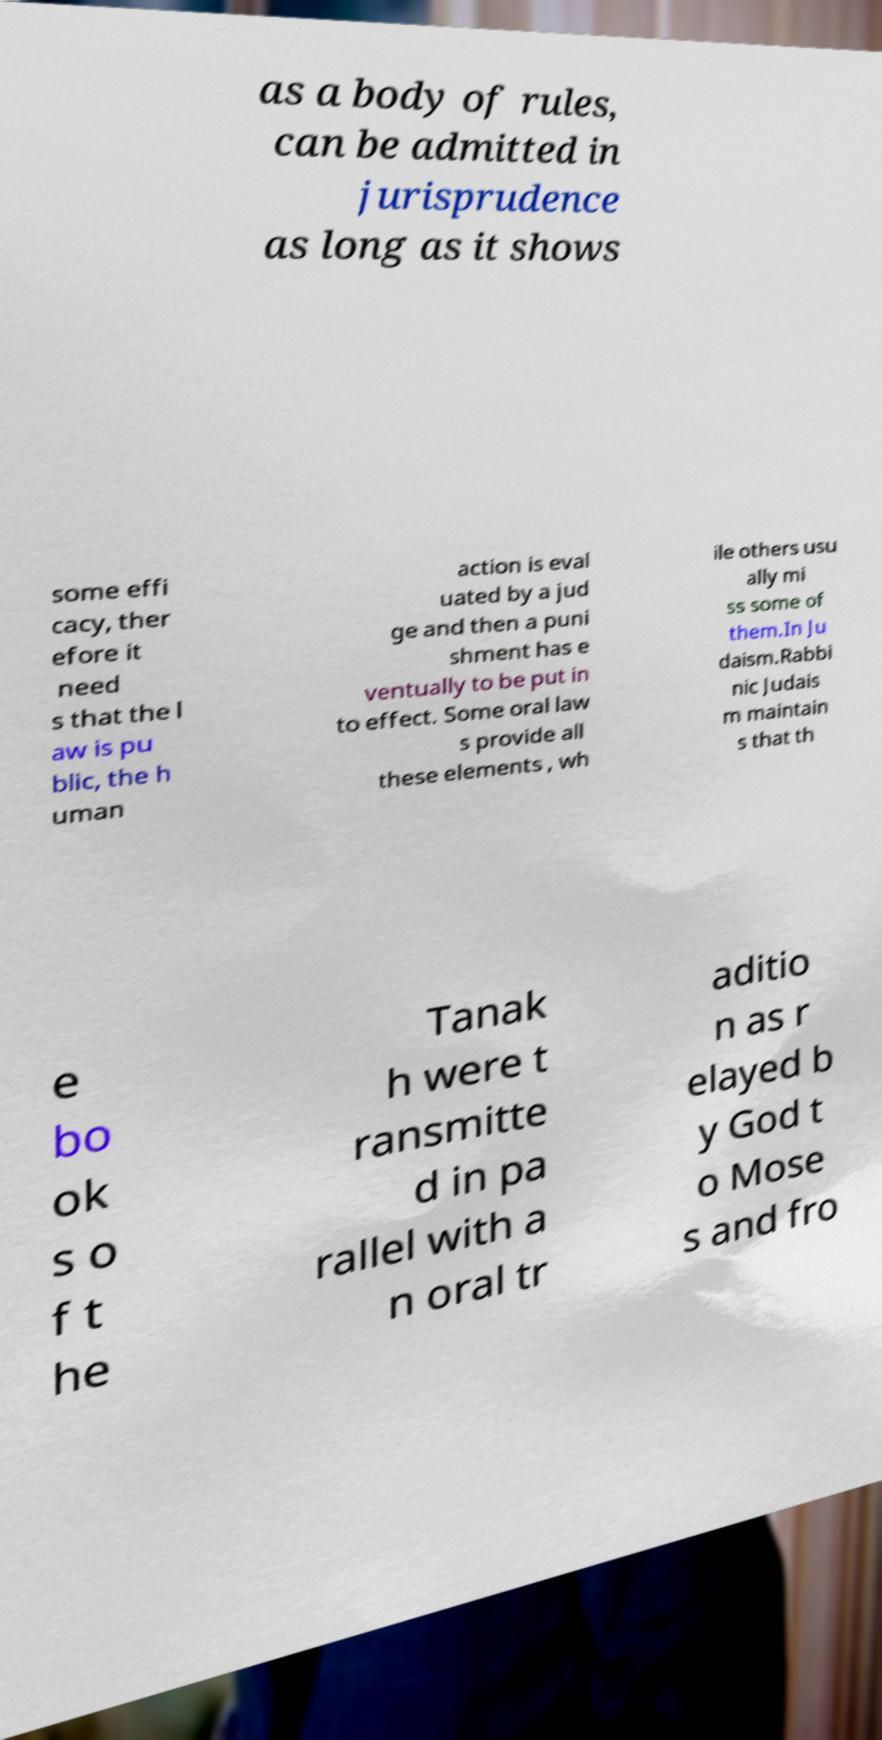For documentation purposes, I need the text within this image transcribed. Could you provide that? as a body of rules, can be admitted in jurisprudence as long as it shows some effi cacy, ther efore it need s that the l aw is pu blic, the h uman action is eval uated by a jud ge and then a puni shment has e ventually to be put in to effect. Some oral law s provide all these elements , wh ile others usu ally mi ss some of them.In Ju daism.Rabbi nic Judais m maintain s that th e bo ok s o f t he Tanak h were t ransmitte d in pa rallel with a n oral tr aditio n as r elayed b y God t o Mose s and fro 